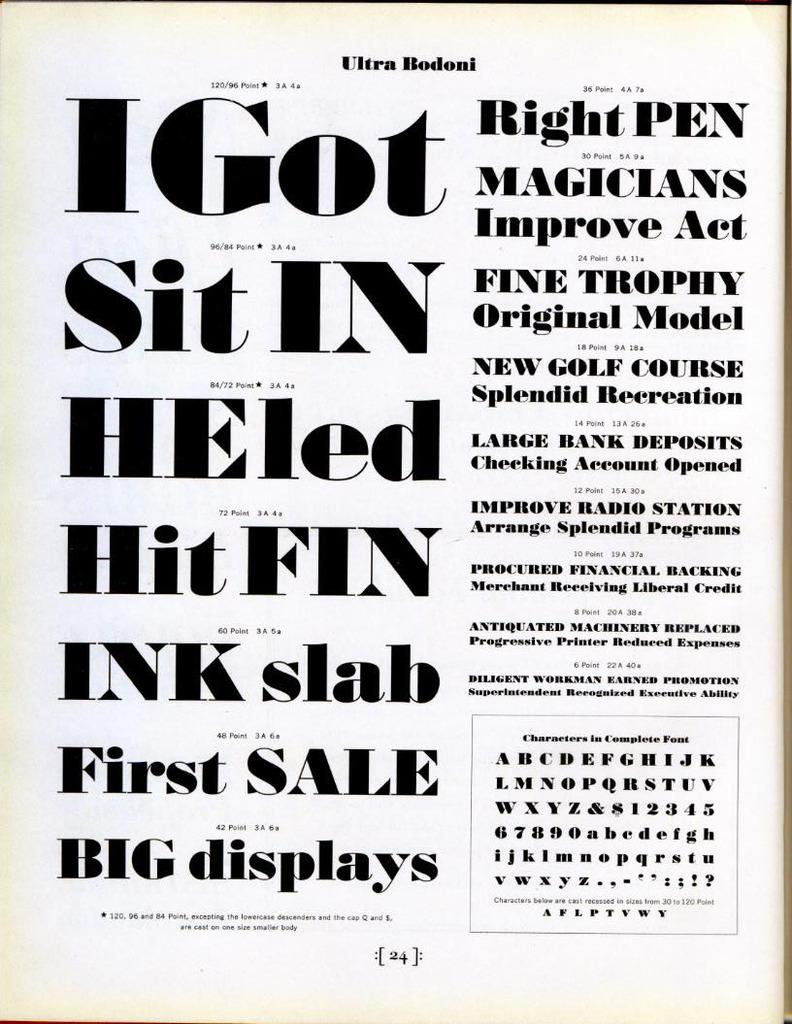What is the word that begins with g?
Provide a succinct answer. Got. What page is this from?
Your response must be concise. Ultra bodoni. 